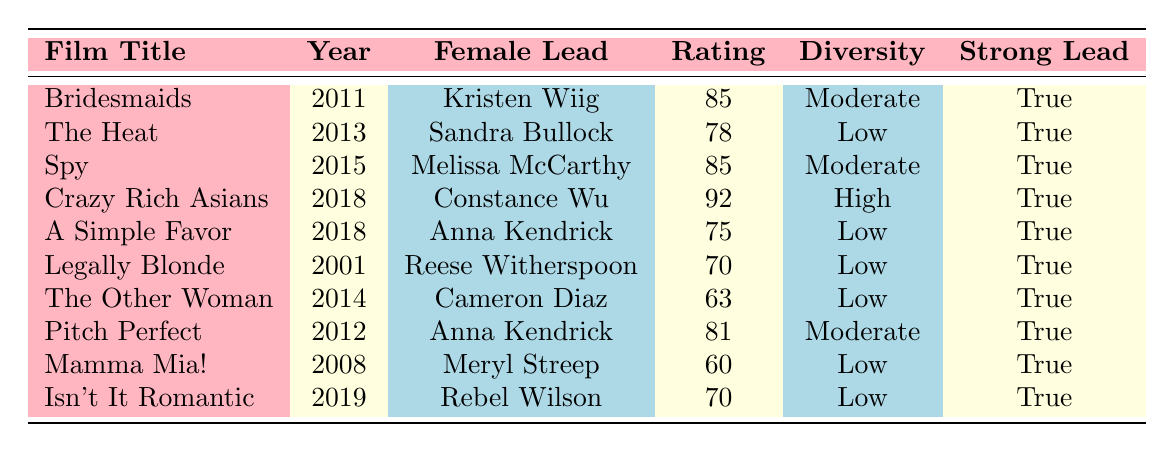What is the audience rating of "Crazy Rich Asians"? The table lists the film "Crazy Rich Asians" along with its audience rating, which is explicitly mentioned in the fourth row. The audience rating is 92.
Answer: 92 Which film has the lowest audience rating among female-led comedies? By examining the table, I can compare the audience ratings for each film. The lowest rating is 60 for "Mamma Mia!" as shown in the eighth row.
Answer: 60 Is "Legally Blonde" a film featuring a strong female lead? The table indicates that "Legally Blonde" is listed under the column for strong female leads and is marked as true.
Answer: Yes In what year was "The Heat" released? The table specifies the release year of each film, and "The Heat" is listed in the second row as having been released in 2013.
Answer: 2013 How many films have a diversity representation categorized as "Low"? To find this, I need to count the rows where diversity representation is "Low". The films are "The Heat," "A Simple Favor," "Legally Blonde," "The Other Woman," "Mamma Mia!," and "Isn't It Romantic," totaling 6 films.
Answer: 6 What is the average audience rating of comedy films featuring strong female leads? First, I sum the audience ratings of all films: (85 + 78 + 85 + 92 + 75 + 70 + 63 + 81 + 60 + 70) = 789. There are 10 films, so the average is 789 divided by 10, which equals 78.9.
Answer: 78.9 Do any films listed have a diversity representation categorized as "High"? Reviewing the table shows that "Crazy Rich Asians" is the only film with a diversity representation categorized as "High," as noted in the fourth row.
Answer: Yes Which female lead had the highest audience rating? Looking at the table, "Crazy Rich Asians" with Constance Wu has the highest audience rating of 92. This can be verified by comparing all ratings in the relevant column.
Answer: Constance Wu What films have both an audience rating above 80 and a moderate diversity representation? From the table, I find that "Bridesmaids," "Spy," and "Pitch Perfect" all have audience ratings above 80. The diversity representation for these films is listed as "Moderate," fitting the criteria.
Answer: Bridesmaids, Spy, Pitch Perfect 